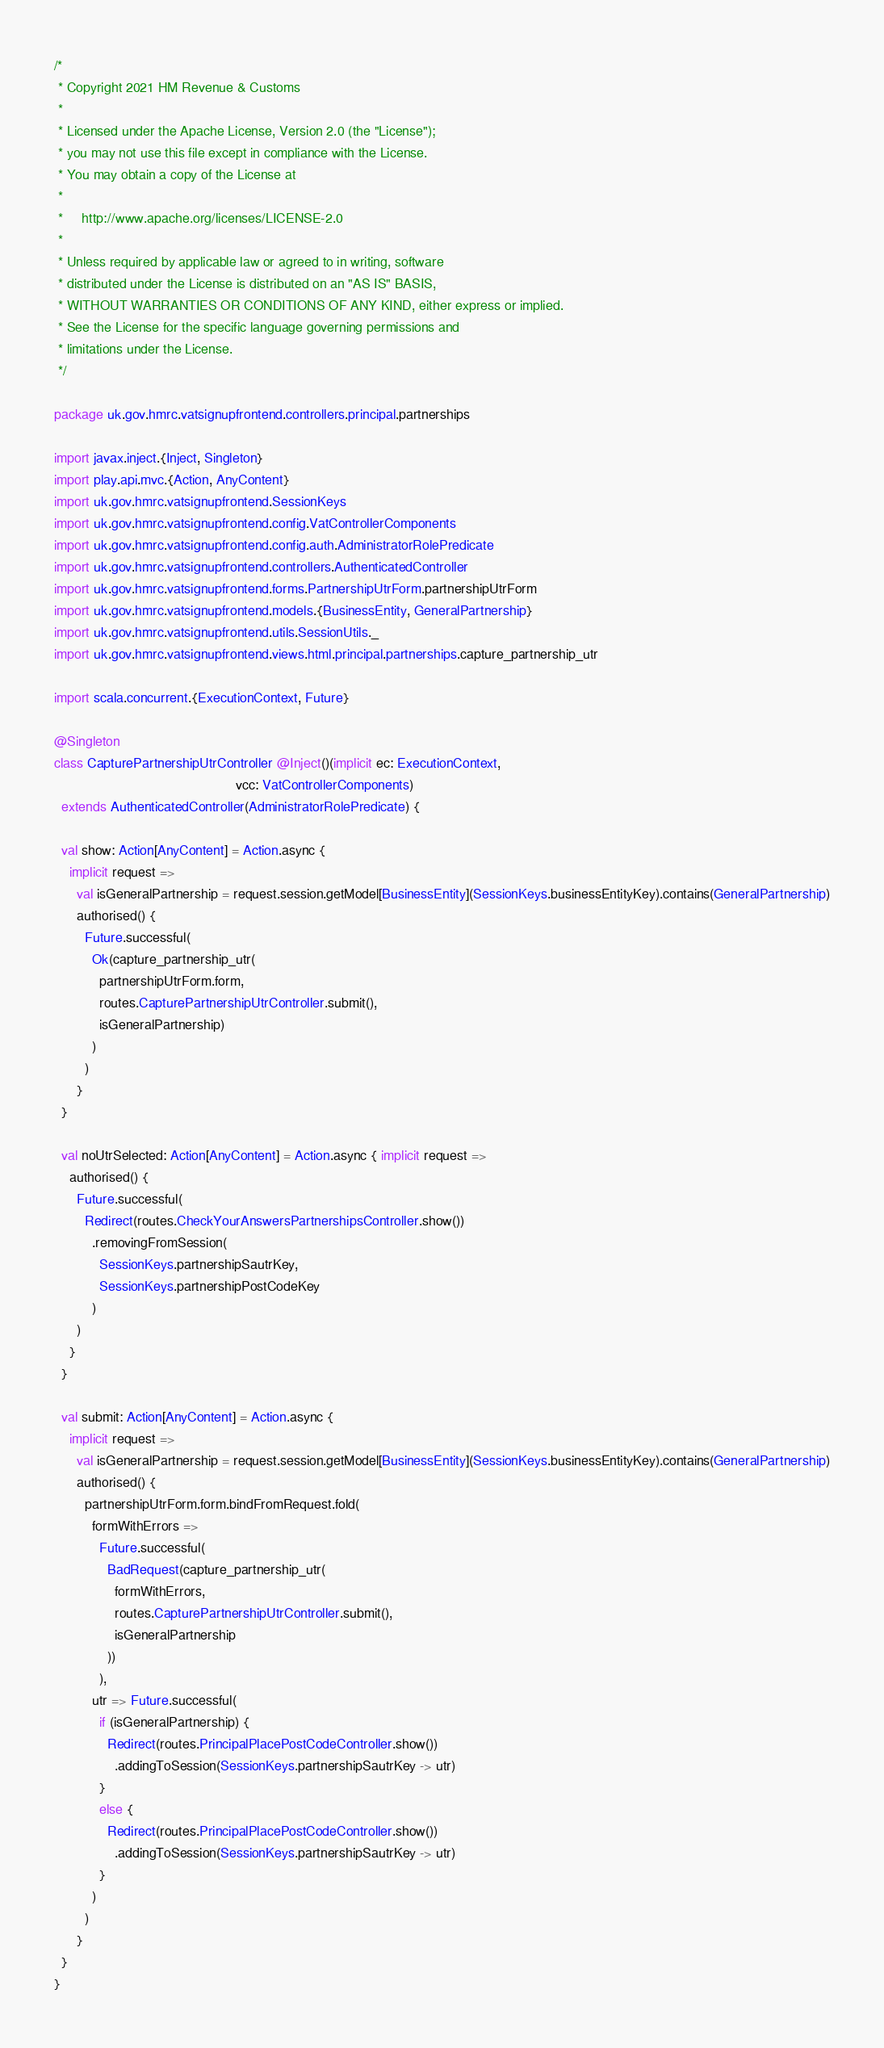Convert code to text. <code><loc_0><loc_0><loc_500><loc_500><_Scala_>/*
 * Copyright 2021 HM Revenue & Customs
 *
 * Licensed under the Apache License, Version 2.0 (the "License");
 * you may not use this file except in compliance with the License.
 * You may obtain a copy of the License at
 *
 *     http://www.apache.org/licenses/LICENSE-2.0
 *
 * Unless required by applicable law or agreed to in writing, software
 * distributed under the License is distributed on an "AS IS" BASIS,
 * WITHOUT WARRANTIES OR CONDITIONS OF ANY KIND, either express or implied.
 * See the License for the specific language governing permissions and
 * limitations under the License.
 */

package uk.gov.hmrc.vatsignupfrontend.controllers.principal.partnerships

import javax.inject.{Inject, Singleton}
import play.api.mvc.{Action, AnyContent}
import uk.gov.hmrc.vatsignupfrontend.SessionKeys
import uk.gov.hmrc.vatsignupfrontend.config.VatControllerComponents
import uk.gov.hmrc.vatsignupfrontend.config.auth.AdministratorRolePredicate
import uk.gov.hmrc.vatsignupfrontend.controllers.AuthenticatedController
import uk.gov.hmrc.vatsignupfrontend.forms.PartnershipUtrForm.partnershipUtrForm
import uk.gov.hmrc.vatsignupfrontend.models.{BusinessEntity, GeneralPartnership}
import uk.gov.hmrc.vatsignupfrontend.utils.SessionUtils._
import uk.gov.hmrc.vatsignupfrontend.views.html.principal.partnerships.capture_partnership_utr

import scala.concurrent.{ExecutionContext, Future}

@Singleton
class CapturePartnershipUtrController @Inject()(implicit ec: ExecutionContext,
                                                vcc: VatControllerComponents)
  extends AuthenticatedController(AdministratorRolePredicate) {

  val show: Action[AnyContent] = Action.async {
    implicit request =>
      val isGeneralPartnership = request.session.getModel[BusinessEntity](SessionKeys.businessEntityKey).contains(GeneralPartnership)
      authorised() {
        Future.successful(
          Ok(capture_partnership_utr(
            partnershipUtrForm.form,
            routes.CapturePartnershipUtrController.submit(),
            isGeneralPartnership)
          )
        )
      }
  }

  val noUtrSelected: Action[AnyContent] = Action.async { implicit request =>
    authorised() {
      Future.successful(
        Redirect(routes.CheckYourAnswersPartnershipsController.show())
          .removingFromSession(
            SessionKeys.partnershipSautrKey,
            SessionKeys.partnershipPostCodeKey
          )
      )
    }
  }

  val submit: Action[AnyContent] = Action.async {
    implicit request =>
      val isGeneralPartnership = request.session.getModel[BusinessEntity](SessionKeys.businessEntityKey).contains(GeneralPartnership)
      authorised() {
        partnershipUtrForm.form.bindFromRequest.fold(
          formWithErrors =>
            Future.successful(
              BadRequest(capture_partnership_utr(
                formWithErrors,
                routes.CapturePartnershipUtrController.submit(),
                isGeneralPartnership
              ))
            ),
          utr => Future.successful(
            if (isGeneralPartnership) {
              Redirect(routes.PrincipalPlacePostCodeController.show())
                .addingToSession(SessionKeys.partnershipSautrKey -> utr)
            }
            else {
              Redirect(routes.PrincipalPlacePostCodeController.show())
                .addingToSession(SessionKeys.partnershipSautrKey -> utr)
            }
          )
        )
      }
  }
}
</code> 